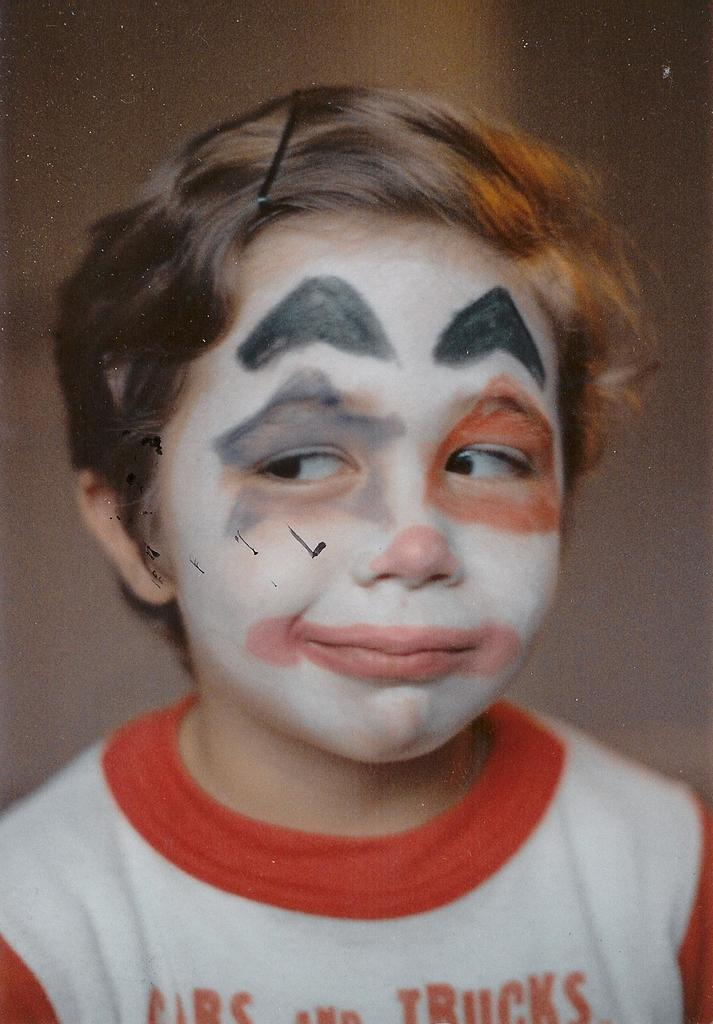Who is the main subject in the image? There is a boy in the image. What is unique about the boy's appearance? The boy has makeup on his face. What is the boy wearing in the image? The boy is wearing a red and white t-shirt. What scientific experiment is the boy conducting in the image? There is no indication of a scientific experiment in the image; it simply shows a boy with makeup on his face and wearing a red and white t-shirt. 